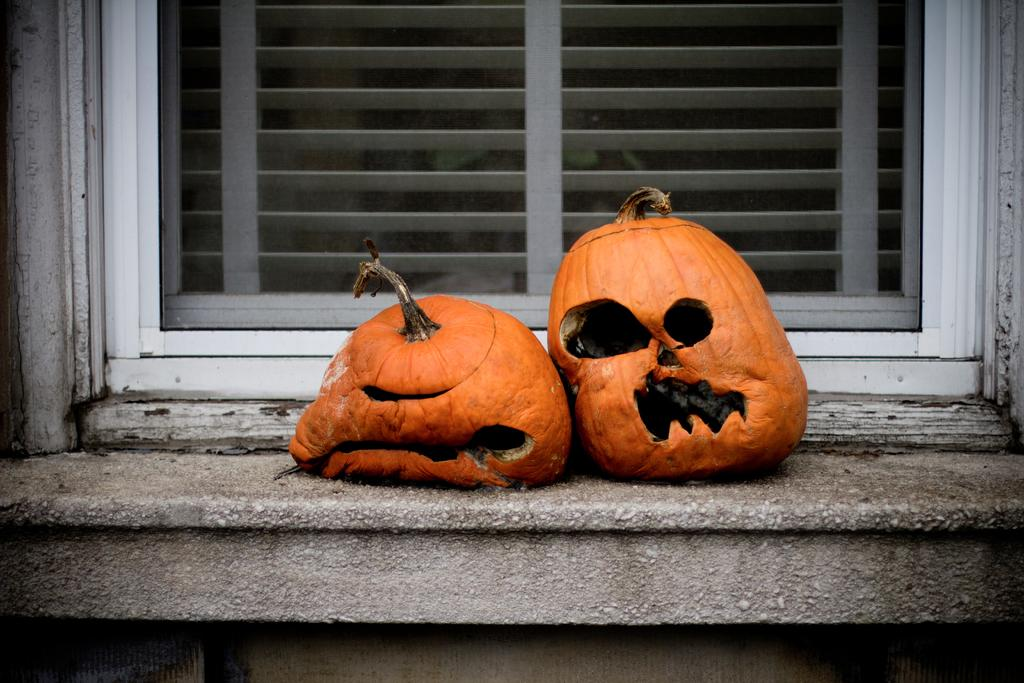How many pumpkins are visible in the image? There are two pumpkins in the image. Where are the pumpkins located? The pumpkins are on a concrete platform. Can you describe any other structures or objects in the image? There is a wooden window in the image. What scientific experiment is being conducted with the pumpkins in the image? There is no scientific experiment being conducted with the pumpkins in the image; they are simply sitting on a concrete platform. 